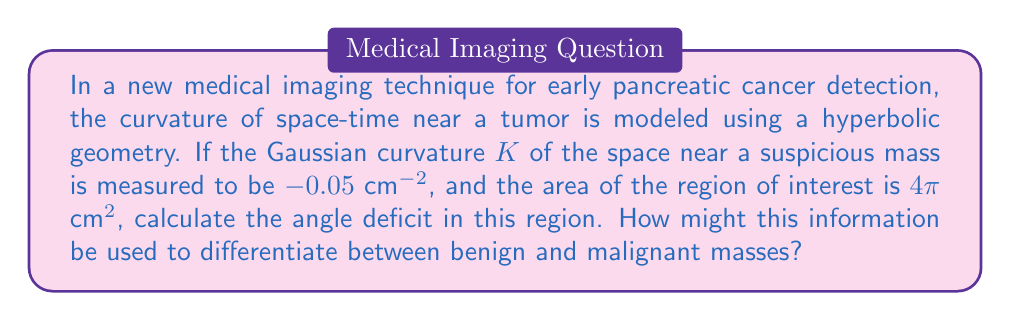Help me with this question. Let's approach this step-by-step:

1) In hyperbolic geometry, the Gauss-Bonnet theorem relates the Gaussian curvature $K$ to the area $A$ and angle deficit $\delta$ of a region:

   $$\int\int_A K dA = 2\pi - \sum \theta_i = -\delta$$

   where $\sum \theta_i$ is the sum of interior angles of the region.

2) For a constant curvature $K$ over the entire area $A$, this simplifies to:

   $$KA = -\delta$$

3) We are given:
   $K = -0.05$ $\text{cm}^{-2}$
   $A = 4\pi$ $\text{cm}^2$

4) Substituting these values:

   $$(-0.05 \text{ cm}^{-2})(4\pi \text{ cm}^2) = -\delta$$

5) Simplifying:

   $$-0.2\pi = -\delta$$

6) Solving for $\delta$:

   $$\delta = 0.2\pi \text{ radians}$$

7) To convert to degrees:

   $$\delta = 0.2\pi \cdot \frac{180°}{\pi} = 36°$$

This angle deficit could potentially be used to differentiate between benign and malignant masses. Malignant tumors might cause more significant distortions in space-time curvature due to their increased density and irregular growth patterns, potentially resulting in larger angle deficits. By establishing baseline measurements for normal tissue and various types of masses, medical professionals could use this information as an additional diagnostic tool for early cancer detection.
Answer: $36°$ 